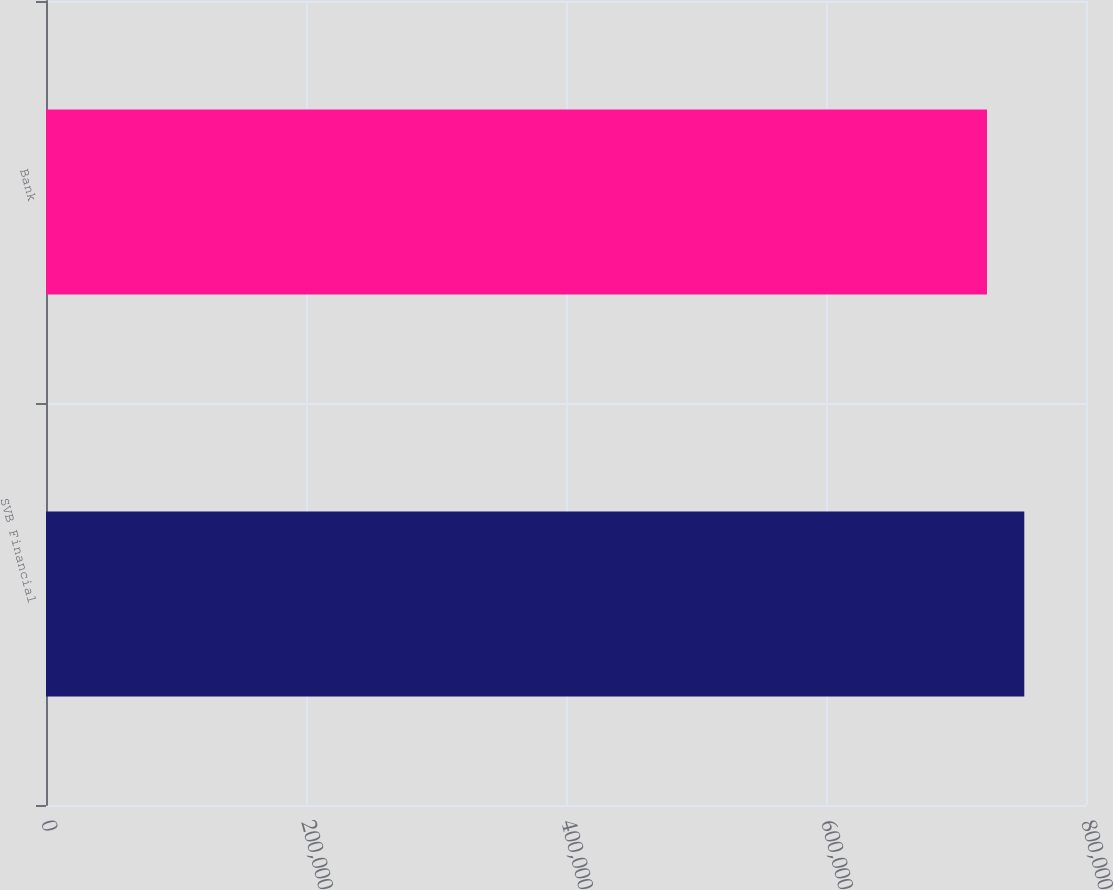<chart> <loc_0><loc_0><loc_500><loc_500><bar_chart><fcel>SVB Financial<fcel>Bank<nl><fcel>752534<fcel>723832<nl></chart> 